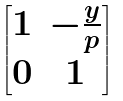<formula> <loc_0><loc_0><loc_500><loc_500>\begin{bmatrix} 1 & - \frac { y } { p } \\ 0 & 1 \end{bmatrix}</formula> 